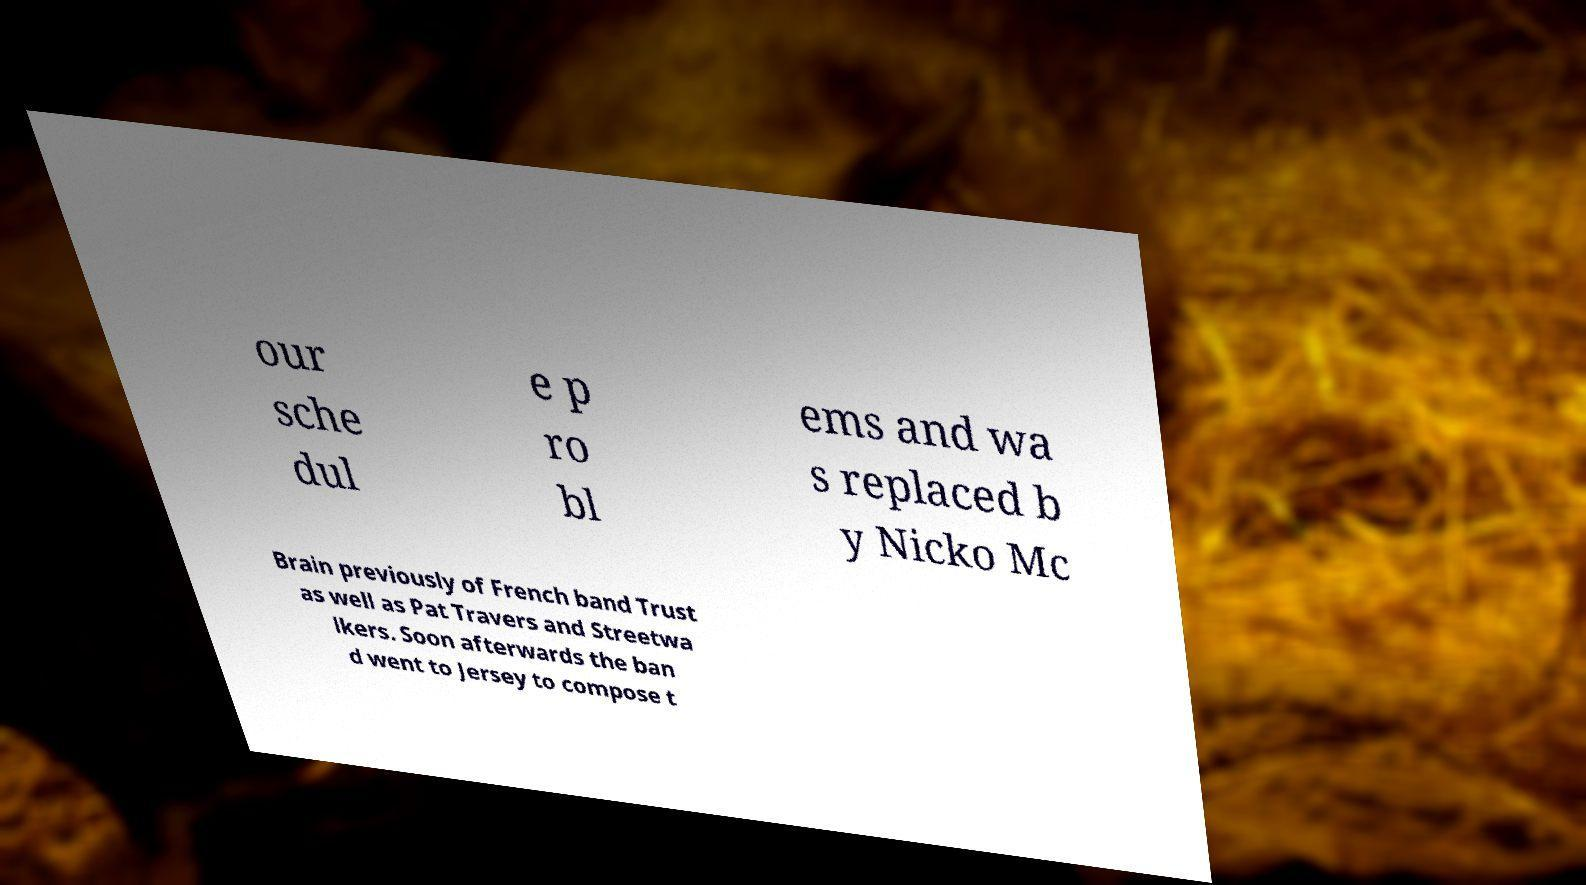For documentation purposes, I need the text within this image transcribed. Could you provide that? our sche dul e p ro bl ems and wa s replaced b y Nicko Mc Brain previously of French band Trust as well as Pat Travers and Streetwa lkers. Soon afterwards the ban d went to Jersey to compose t 